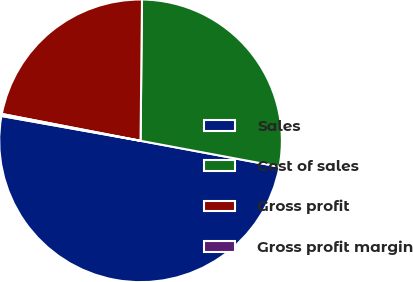Convert chart. <chart><loc_0><loc_0><loc_500><loc_500><pie_chart><fcel>Sales<fcel>Cost of sales<fcel>Gross profit<fcel>Gross profit margin<nl><fcel>49.88%<fcel>27.77%<fcel>22.12%<fcel>0.23%<nl></chart> 